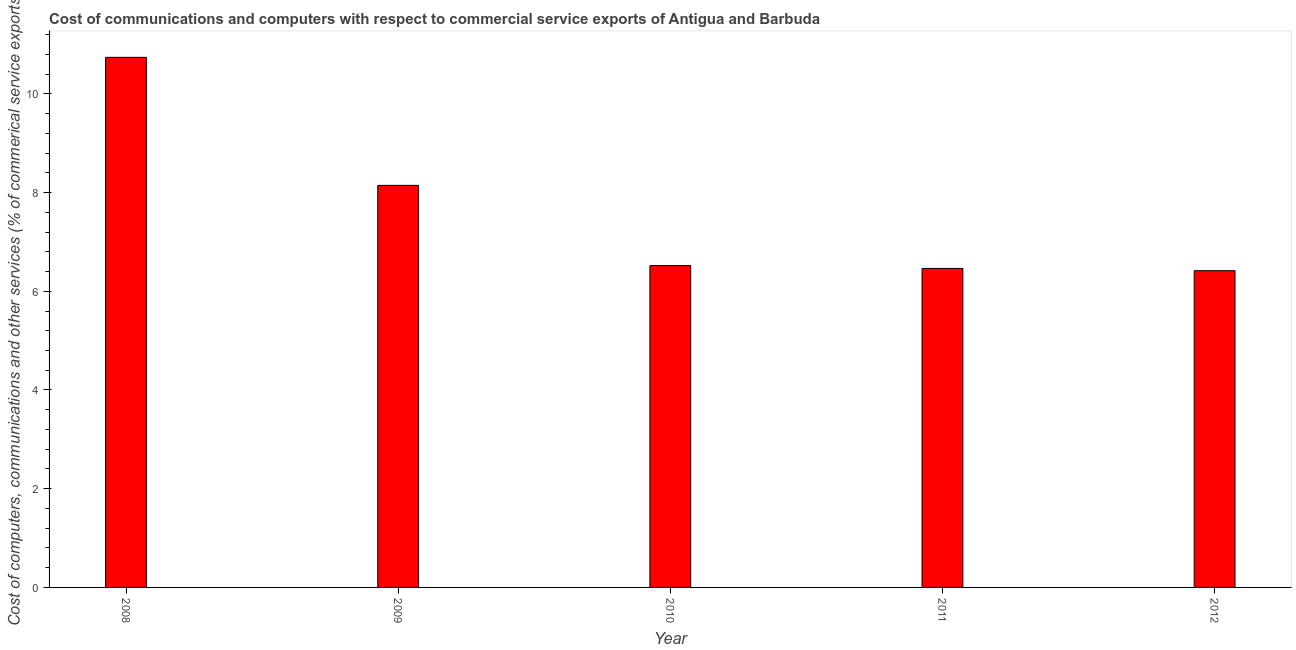Does the graph contain grids?
Provide a short and direct response. No. What is the title of the graph?
Your answer should be compact. Cost of communications and computers with respect to commercial service exports of Antigua and Barbuda. What is the label or title of the Y-axis?
Give a very brief answer. Cost of computers, communications and other services (% of commerical service exports). What is the cost of communications in 2008?
Keep it short and to the point. 10.74. Across all years, what is the maximum cost of communications?
Your response must be concise. 10.74. Across all years, what is the minimum  computer and other services?
Your answer should be compact. 6.42. In which year was the cost of communications minimum?
Give a very brief answer. 2012. What is the sum of the  computer and other services?
Your answer should be compact. 38.29. What is the difference between the  computer and other services in 2010 and 2012?
Provide a short and direct response. 0.1. What is the average cost of communications per year?
Your answer should be very brief. 7.66. What is the median cost of communications?
Your response must be concise. 6.52. What is the ratio of the  computer and other services in 2011 to that in 2012?
Provide a short and direct response. 1.01. Is the cost of communications in 2010 less than that in 2012?
Your answer should be compact. No. Is the difference between the cost of communications in 2008 and 2011 greater than the difference between any two years?
Make the answer very short. No. What is the difference between the highest and the second highest cost of communications?
Make the answer very short. 2.59. Is the sum of the cost of communications in 2009 and 2012 greater than the maximum cost of communications across all years?
Offer a terse response. Yes. What is the difference between the highest and the lowest cost of communications?
Make the answer very short. 4.32. Are all the bars in the graph horizontal?
Offer a terse response. No. What is the Cost of computers, communications and other services (% of commerical service exports) in 2008?
Give a very brief answer. 10.74. What is the Cost of computers, communications and other services (% of commerical service exports) in 2009?
Your answer should be very brief. 8.15. What is the Cost of computers, communications and other services (% of commerical service exports) of 2010?
Your answer should be compact. 6.52. What is the Cost of computers, communications and other services (% of commerical service exports) in 2011?
Offer a terse response. 6.46. What is the Cost of computers, communications and other services (% of commerical service exports) of 2012?
Offer a terse response. 6.42. What is the difference between the Cost of computers, communications and other services (% of commerical service exports) in 2008 and 2009?
Give a very brief answer. 2.59. What is the difference between the Cost of computers, communications and other services (% of commerical service exports) in 2008 and 2010?
Your answer should be very brief. 4.22. What is the difference between the Cost of computers, communications and other services (% of commerical service exports) in 2008 and 2011?
Offer a terse response. 4.28. What is the difference between the Cost of computers, communications and other services (% of commerical service exports) in 2008 and 2012?
Provide a short and direct response. 4.32. What is the difference between the Cost of computers, communications and other services (% of commerical service exports) in 2009 and 2010?
Your answer should be very brief. 1.63. What is the difference between the Cost of computers, communications and other services (% of commerical service exports) in 2009 and 2011?
Your answer should be compact. 1.68. What is the difference between the Cost of computers, communications and other services (% of commerical service exports) in 2009 and 2012?
Make the answer very short. 1.73. What is the difference between the Cost of computers, communications and other services (% of commerical service exports) in 2010 and 2011?
Your response must be concise. 0.06. What is the difference between the Cost of computers, communications and other services (% of commerical service exports) in 2010 and 2012?
Offer a terse response. 0.1. What is the difference between the Cost of computers, communications and other services (% of commerical service exports) in 2011 and 2012?
Your response must be concise. 0.05. What is the ratio of the Cost of computers, communications and other services (% of commerical service exports) in 2008 to that in 2009?
Make the answer very short. 1.32. What is the ratio of the Cost of computers, communications and other services (% of commerical service exports) in 2008 to that in 2010?
Offer a very short reply. 1.65. What is the ratio of the Cost of computers, communications and other services (% of commerical service exports) in 2008 to that in 2011?
Your response must be concise. 1.66. What is the ratio of the Cost of computers, communications and other services (% of commerical service exports) in 2008 to that in 2012?
Ensure brevity in your answer.  1.67. What is the ratio of the Cost of computers, communications and other services (% of commerical service exports) in 2009 to that in 2010?
Your answer should be very brief. 1.25. What is the ratio of the Cost of computers, communications and other services (% of commerical service exports) in 2009 to that in 2011?
Keep it short and to the point. 1.26. What is the ratio of the Cost of computers, communications and other services (% of commerical service exports) in 2009 to that in 2012?
Your answer should be compact. 1.27. What is the ratio of the Cost of computers, communications and other services (% of commerical service exports) in 2010 to that in 2012?
Your answer should be very brief. 1.02. What is the ratio of the Cost of computers, communications and other services (% of commerical service exports) in 2011 to that in 2012?
Offer a terse response. 1.01. 